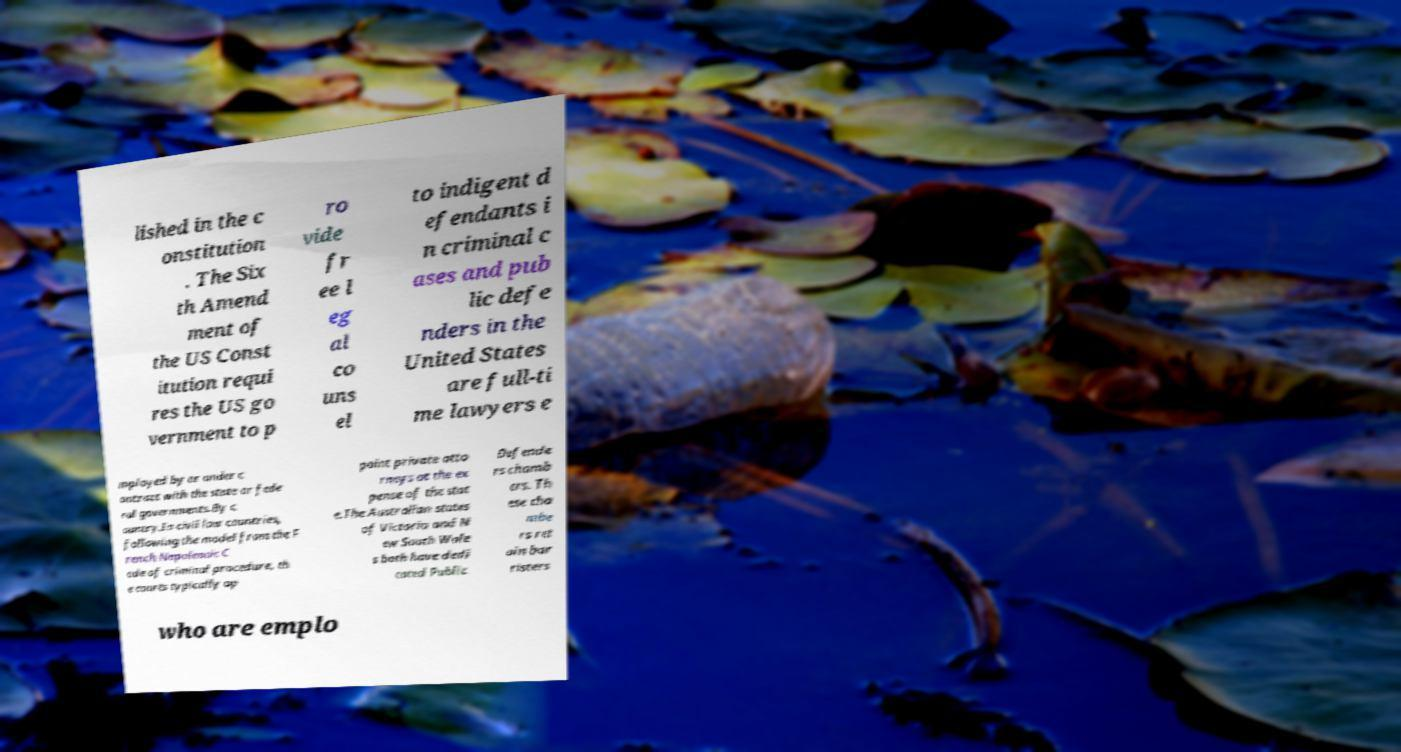I need the written content from this picture converted into text. Can you do that? lished in the c onstitution . The Six th Amend ment of the US Const itution requi res the US go vernment to p ro vide fr ee l eg al co uns el to indigent d efendants i n criminal c ases and pub lic defe nders in the United States are full-ti me lawyers e mployed by or under c ontract with the state or fede ral governments.By c ountry.In civil law countries, following the model from the F rench Napoleonic C ode of criminal procedure, th e courts typically ap point private atto rneys at the ex pense of the stat e.The Australian states of Victoria and N ew South Wale s both have dedi cated Public Defende rs chamb ers. Th ese cha mbe rs ret ain bar risters who are emplo 